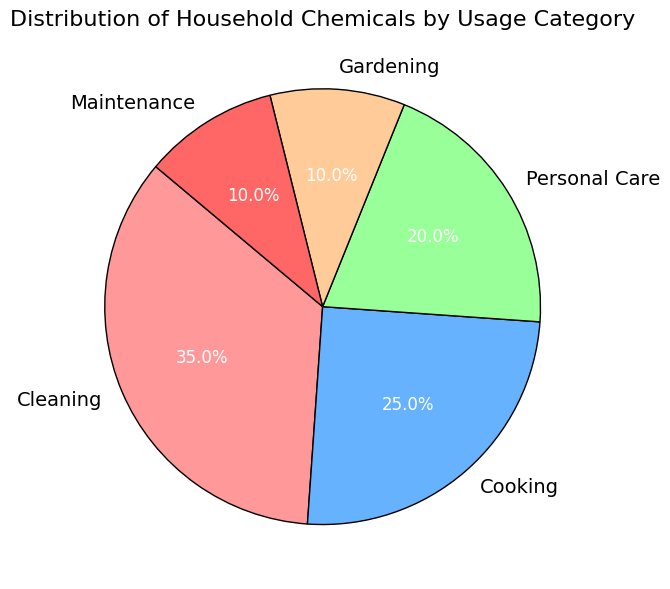What percentage of household chemicals is related to cleaning? The pie chart shows the categories and their corresponding percentages. The slice labeled 'Cleaning' indicates its value.
Answer: 35% Which category uses a higher percentage of household chemicals, Cooking or Gardening? The labels 'Cooking' and 'Gardening' on the pie chart show their respective percentages. Comparing them, Cooking has 25% and Gardening has 10%.
Answer: Cooking What is the combined percentage of household chemicals used for Cleaning and Personal Care? Add the percentages for Cleaning and Personal Care from the pie chart: 35% (Cleaning) + 20% (Personal Care).
Answer: 55% Which category has the smallest percentage share? Look at all the category labels in the pie chart and identify the one with the lowest percentage. Both Gardening and Maintenance have 10%, so they're the smallest.
Answer: Gardening and Maintenance If the percentage of household chemicals for Maintenance is increased by 5%, what would be its new percentage? The current percentage for Maintenance is 10%. Adding 5% gives a new percentage: 10% + 5%.
Answer: 15% Is the percentage of household chemicals used for Cooking more than half of that for Cleaning? Compare half of the Cleaning percentage (35% / 2 = 17.5%) with the Cooking percentage (25%). Since 25% is greater than 17.5%, Cooking is more than half of Cleaning.
Answer: Yes What percentage difference is there between Personal Care and Gardening? Subtract the percentage for Gardening from Personal Care: 20% (Personal Care) - 10% (Gardening).
Answer: 10% Which colored slice represents the Personal Care category? Observing the color of the slice labeled 'Personal Care' on the pie chart, it is green.
Answer: Green How much more percentage is used for Cleaning compared to Maintenance? Subtract the percentage for Maintenance from Cleaning: 35% (Cleaning) - 10% (Maintenance).
Answer: 25% Are the percentages for Gardening and Maintenance equal? Compare the percentages for Gardening and Maintenance, both are 10%.
Answer: Yes 